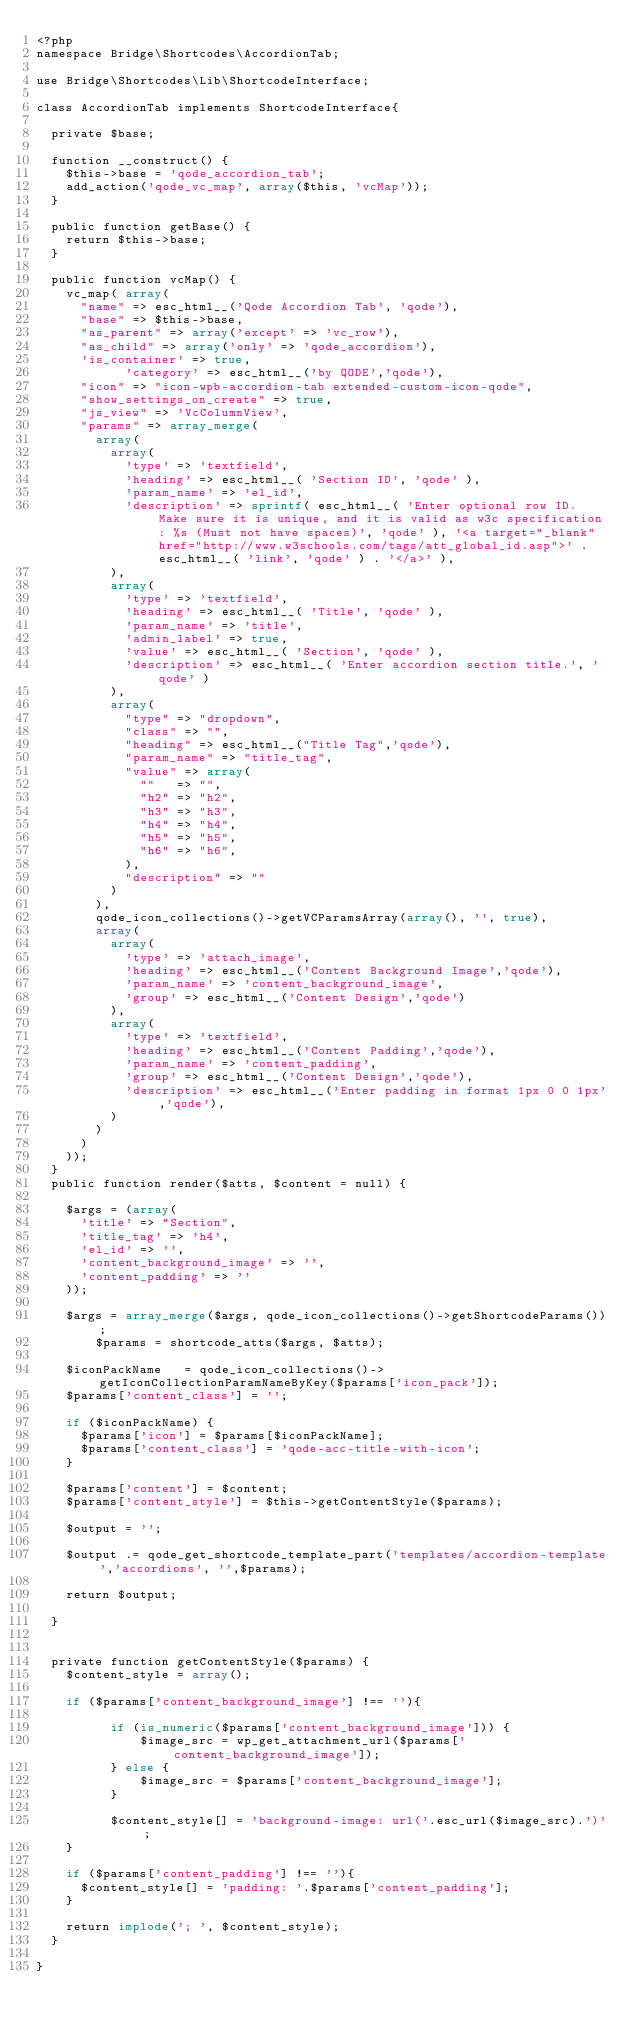Convert code to text. <code><loc_0><loc_0><loc_500><loc_500><_PHP_><?php 
namespace Bridge\Shortcodes\AccordionTab;

use Bridge\Shortcodes\Lib\ShortcodeInterface;

class AccordionTab implements ShortcodeInterface{

	private $base;

	function __construct() {
		$this->base = 'qode_accordion_tab';
		add_action('qode_vc_map', array($this, 'vcMap'));
	}

	public function getBase() {
		return $this->base;
	}
	
	public function vcMap() {
		vc_map( array(
			"name" => esc_html__('Qode Accordion Tab', 'qode'),
			"base" => $this->base,
			"as_parent" => array('except' => 'vc_row'),
			"as_child" => array('only' => 'qode_accordion'),
			'is_container' => true,
            'category' => esc_html__('by QODE','qode'),
			"icon" => "icon-wpb-accordion-tab extended-custom-icon-qode",
			"show_settings_on_create" => true,
			"js_view" => 'VcColumnView',
			"params" => array_merge(
				array(
					array(
						'type' => 'textfield',
						'heading' => esc_html__( 'Section ID', 'qode' ),
						'param_name' => 'el_id',
						'description' => sprintf( esc_html__( 'Enter optional row ID. Make sure it is unique, and it is valid as w3c specification: %s (Must not have spaces)', 'qode' ), '<a target="_blank" href="http://www.w3schools.com/tags/att_global_id.asp">' . esc_html__( 'link', 'qode' ) . '</a>' ),
					),
					array(
						'type' => 'textfield',
						'heading' => esc_html__( 'Title', 'qode' ),
						'param_name' => 'title',
						'admin_label' => true,
						'value' => esc_html__( 'Section', 'qode' ),
						'description' => esc_html__( 'Enter accordion section title.', 'qode' )
					),
					array(
						"type" => "dropdown",
						"class" => "",
						"heading" => esc_html__("Title Tag",'qode'),
						"param_name" => "title_tag",
						"value" => array(
							""   => "",
							"h2" => "h2",
							"h3" => "h3",
							"h4" => "h4",
							"h5" => "h5",
							"h6" => "h6",
						),
						"description" => ""
					)
				),
				qode_icon_collections()->getVCParamsArray(array(), '', true),
				array(
					array(
						'type' => 'attach_image',
						'heading' => esc_html__('Content Background Image','qode'),
						'param_name' => 'content_background_image',
						'group' => esc_html__('Content Design','qode')
					),
					array(
						'type' => 'textfield',
						'heading' => esc_html__('Content Padding','qode'),
						'param_name' => 'content_padding',
						'group' => esc_html__('Content Design','qode'),
						'description' => esc_html__('Enter padding in format 1px 0 0 1px','qode'),
					)
				)
			)
		));
	}	
	public function render($atts, $content = null) {

		$args = (array(
			'title'	=> "Section",
			'title_tag' => 'h4',
			'el_id' => '',
			'content_background_image' => '',
			'content_padding' => ''
		));
		
		$args	= array_merge($args, qode_icon_collections()->getShortcodeParams());
        $params	= shortcode_atts($args, $atts);

		$iconPackName   = qode_icon_collections()->getIconCollectionParamNameByKey($params['icon_pack']);
		$params['content_class'] = '';

		if ($iconPackName) {
			$params['icon'] = $params[$iconPackName];
			$params['content_class'] = 'qode-acc-title-with-icon';
		}

		$params['content'] = $content;
		$params['content_style'] = $this->getContentStyle($params);
		
		$output = '';
		
		$output .= qode_get_shortcode_template_part('templates/accordion-template','accordions', '',$params);

		return $output;
		
	}


	private function getContentStyle($params) {
		$content_style = array();

		if ($params['content_background_image'] !== ''){

	        if (is_numeric($params['content_background_image'])) {
	            $image_src = wp_get_attachment_url($params['content_background_image']);
	        } else {
	            $image_src = $params['content_background_image'];
	        }

	        $content_style[] = 'background-image: url('.esc_url($image_src).')';
		}

		if ($params['content_padding'] !== ''){
			$content_style[] = 'padding: '.$params['content_padding'];
		}

		return implode('; ', $content_style);
	}

}</code> 